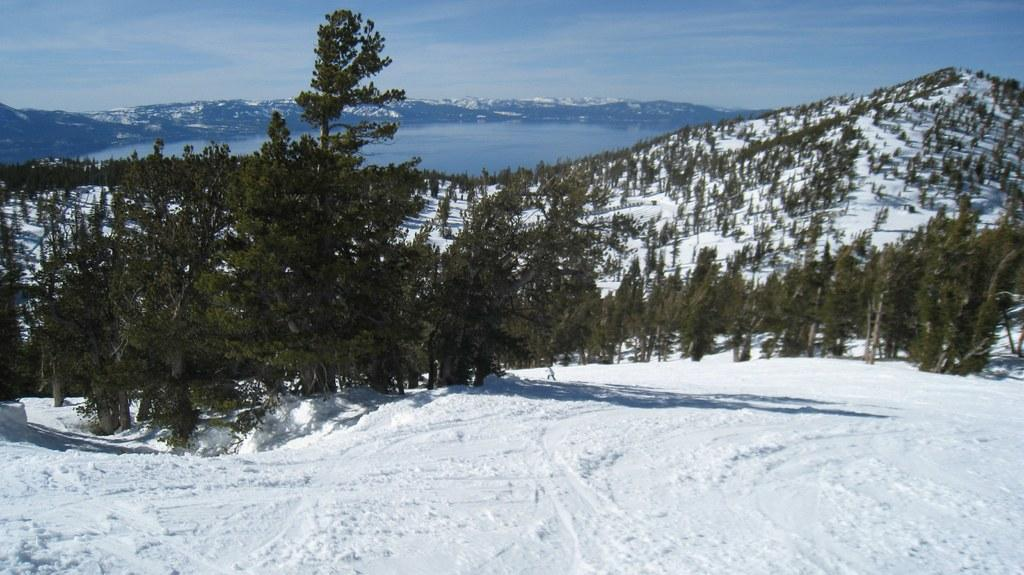What type of vegetation can be seen in the image? There are trees in the image. What natural element is visible in the image? There is water visible in the image. How would you describe the sky in the image? The sky is blue and cloudy in the image. What type of weather condition is suggested by the presence of snow in the image? The presence of snow in the image suggests a cold weather condition. Where is the plantation located in the image? There is no plantation present in the image. What is your opinion about the bridge in the image? There is no bridge present in the image, so it is not possible to provide an opinion about it. 